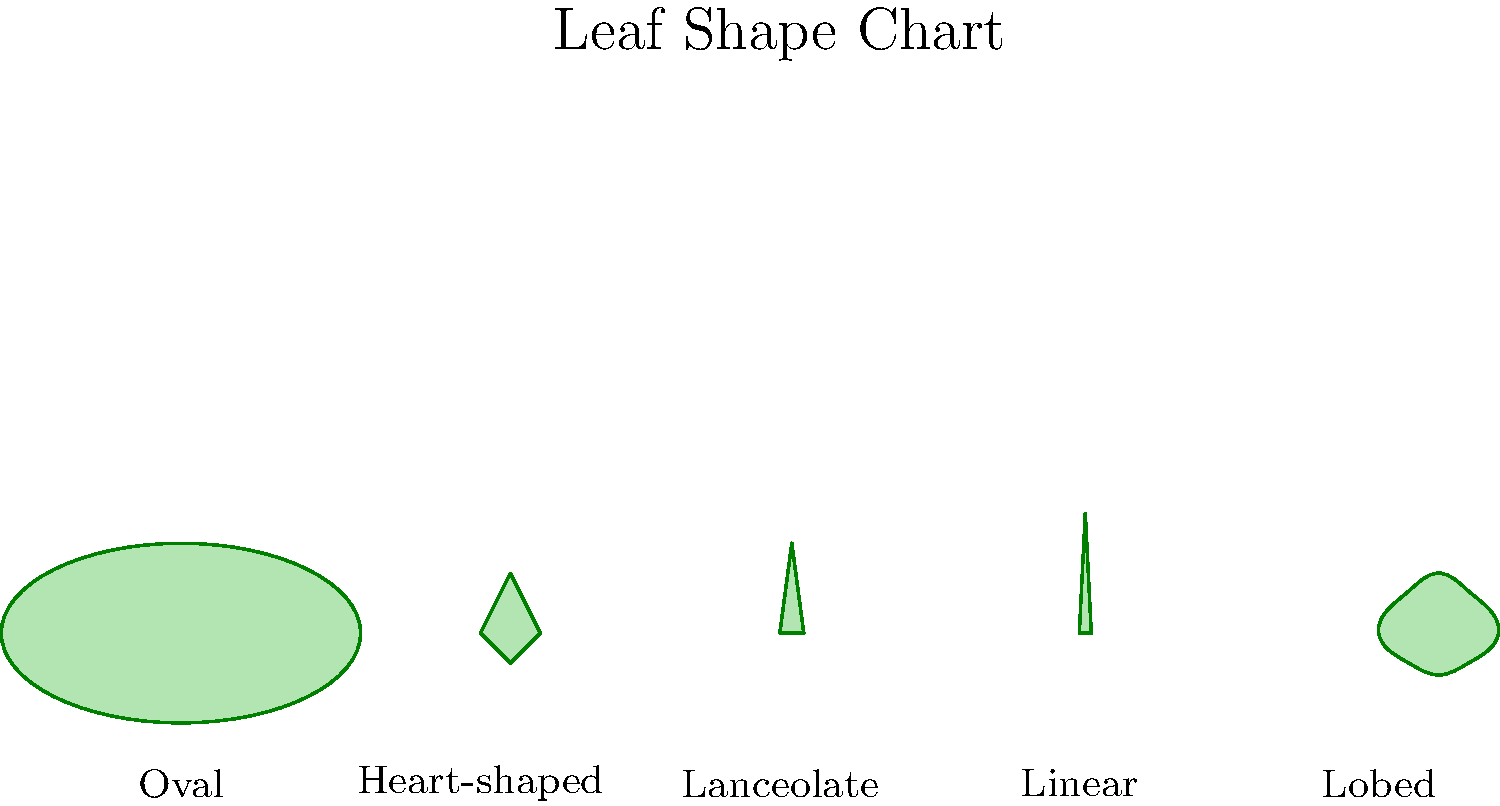As a home gardener interested in genetic diversity, you're studying different leaf shapes. Using the leaf shape chart provided, which leaf shape is typically associated with the highest level of genetic diversity within a plant species, and why might this be important for your garden's resilience? To answer this question, let's consider the following steps:

1. Examine the leaf shapes in the chart: Oval, Heart-shaped, Lanceolate, Linear, and Lobed.

2. Consider genetic diversity: In general, more complex leaf shapes often indicate higher genetic diversity within a species.

3. Identify the most complex shape: Among the given options, the Lobed leaf shape is the most complex, with multiple indentations and curves.

4. Understand the importance of genetic diversity:
   a) Resilience to pests and diseases: Plants with higher genetic diversity are often more resistant to various threats.
   b) Adaptability to environmental changes: Diverse populations can better adapt to changing conditions.
   c) Improved pollination: Diverse plants may attract a wider range of pollinators.

5. Apply to gardening:
   a) Selecting plants with lobed leaves might indicate choosing species with higher genetic diversity.
   b) This could lead to a more resilient and adaptable garden ecosystem.

6. Consider limitations: While leaf shape can be an indicator, it's not the only factor in genetic diversity. Other characteristics and scientific studies should also be considered for a comprehensive understanding.
Answer: Lobed; higher genetic diversity improves garden resilience through better pest resistance and environmental adaptability. 